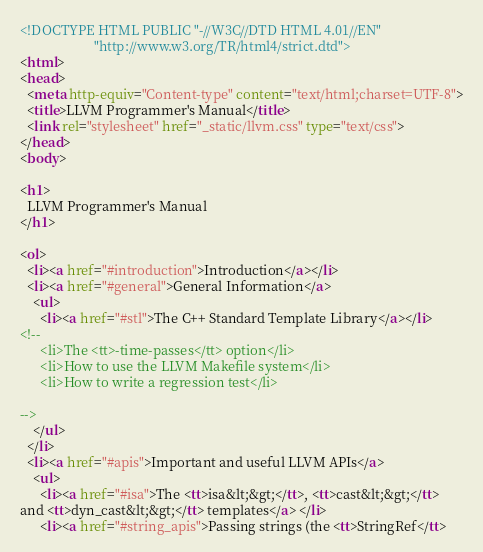<code> <loc_0><loc_0><loc_500><loc_500><_HTML_><!DOCTYPE HTML PUBLIC "-//W3C//DTD HTML 4.01//EN"
                      "http://www.w3.org/TR/html4/strict.dtd">
<html>
<head>
  <meta http-equiv="Content-type" content="text/html;charset=UTF-8">
  <title>LLVM Programmer's Manual</title>
  <link rel="stylesheet" href="_static/llvm.css" type="text/css">
</head>
<body>

<h1>
  LLVM Programmer's Manual
</h1>

<ol>
  <li><a href="#introduction">Introduction</a></li>
  <li><a href="#general">General Information</a>
    <ul>
      <li><a href="#stl">The C++ Standard Template Library</a></li>
<!--
      <li>The <tt>-time-passes</tt> option</li>
      <li>How to use the LLVM Makefile system</li>
      <li>How to write a regression test</li>

--> 
    </ul>
  </li>
  <li><a href="#apis">Important and useful LLVM APIs</a>
    <ul>
      <li><a href="#isa">The <tt>isa&lt;&gt;</tt>, <tt>cast&lt;&gt;</tt>
and <tt>dyn_cast&lt;&gt;</tt> templates</a> </li>
      <li><a href="#string_apis">Passing strings (the <tt>StringRef</tt></code> 